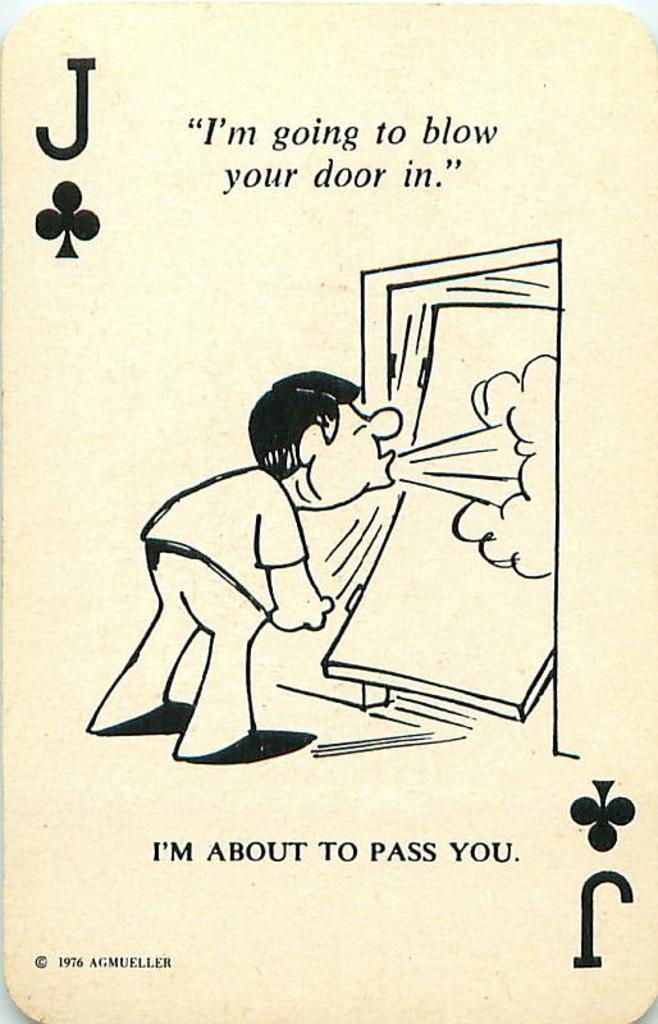What is the main object in the image? There is a card in the image. What can be seen on the card? The card contains a depiction of a person. Is there any text on the card? Yes, there is text on the card. What type of linen is used to create the card in the image? There is no information about the material used to create the card in the image. 